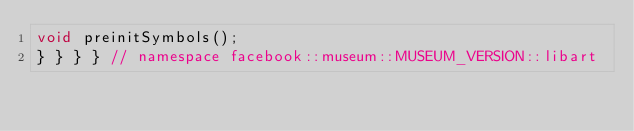Convert code to text. <code><loc_0><loc_0><loc_500><loc_500><_C_>void preinitSymbols();
} } } } // namespace facebook::museum::MUSEUM_VERSION::libart
</code> 